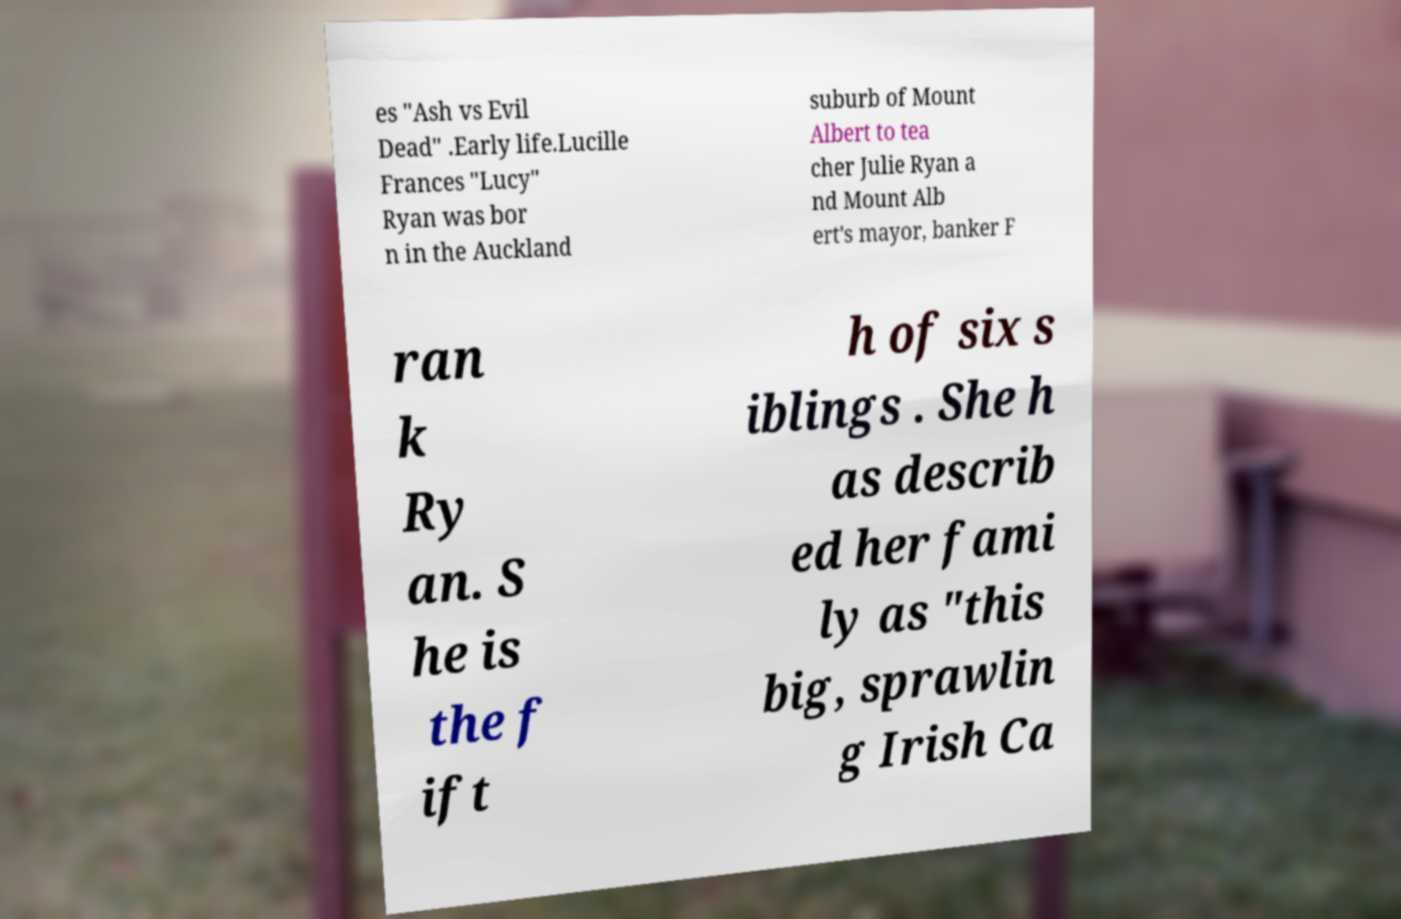Can you read and provide the text displayed in the image?This photo seems to have some interesting text. Can you extract and type it out for me? es "Ash vs Evil Dead" .Early life.Lucille Frances "Lucy" Ryan was bor n in the Auckland suburb of Mount Albert to tea cher Julie Ryan a nd Mount Alb ert's mayor, banker F ran k Ry an. S he is the f ift h of six s iblings . She h as describ ed her fami ly as "this big, sprawlin g Irish Ca 